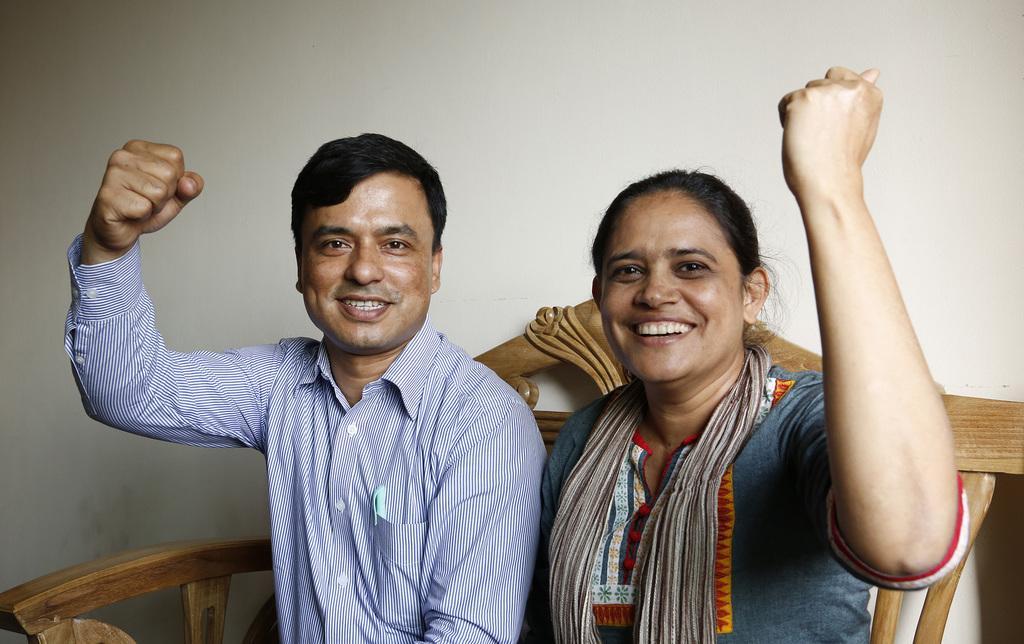Can you describe this image briefly? In this picture we can see a man and a woman and they are smiling and in the background we can see a wooden object and the wall. 